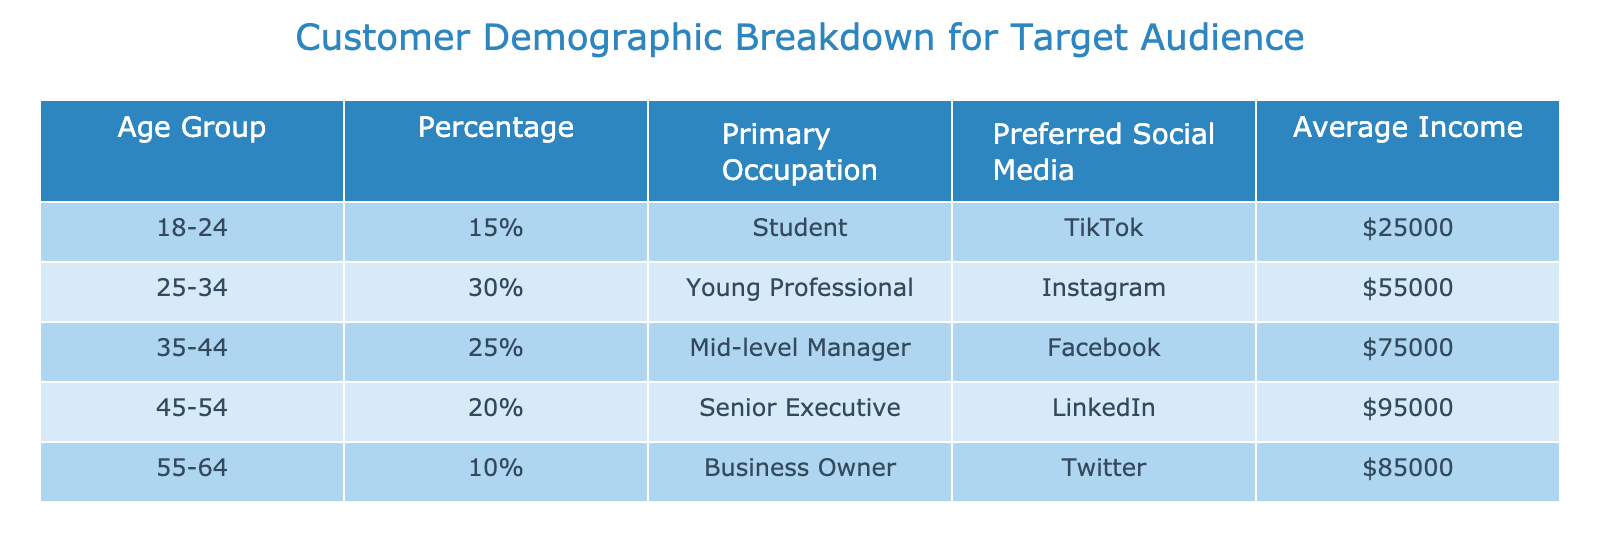What is the percentage of people aged 18-24 in the target audience? The table shows that the percentage of the age group 18-24 is explicitly listed as 15%.
Answer: 15% Which age group has the highest average income? By looking at the average income column, the age group 45-54 has the highest average income listed at $95,000.
Answer: 45-54 Is there a specific social media platform that young professionals prefer? The table indicates that the primary occupation for the age group 25-34, which is young professionals, is Instagram. Therefore, yes, young professionals prefer Instagram.
Answer: Yes What is the combined percentage of people aged 35-44 and 45-54? To find this, we add the percentages of the two age groups: 25% (35-44) + 20% (45-54) = 45%.
Answer: 45% Which age group has a preferred social media of Twitter? Referring to the table, the age group 55-64 has the preferred social media platform listed as Twitter.
Answer: 55-64 What is the average income of the age group 18-24 compared to 55-64? The average income for age group 18-24 is $25,000, while for 55-64 it is $85,000. The difference then is $85,000 - $25,000 = $60,000.
Answer: $60,000 Do more senior executives prefer LinkedIn over Facebook? Examining the table, senior executives (age 45-54) prefer LinkedIn, while mid-level managers (age 35-44) prefer Facebook. The question is comparing two different occupations and their preferred platforms; thus, the answer is yes, since senior executives use LinkedIn, which is a more professional platform compared to Facebook.
Answer: Yes What is the total average income of all age groups combined? To find the total average income, we sum the average incomes of all age groups: $25,000 + $55,000 + $75,000 + $95,000 + $85,000 = $335,000. Then, we divide it by the number of age groups (5) to find the overall average: $335,000 / 5 = $67,000.
Answer: $67,000 Which age group has the lowest percentage? Looking at the table, the age group 55-64 has the lowest percentage, which is 10%.
Answer: 55-64 